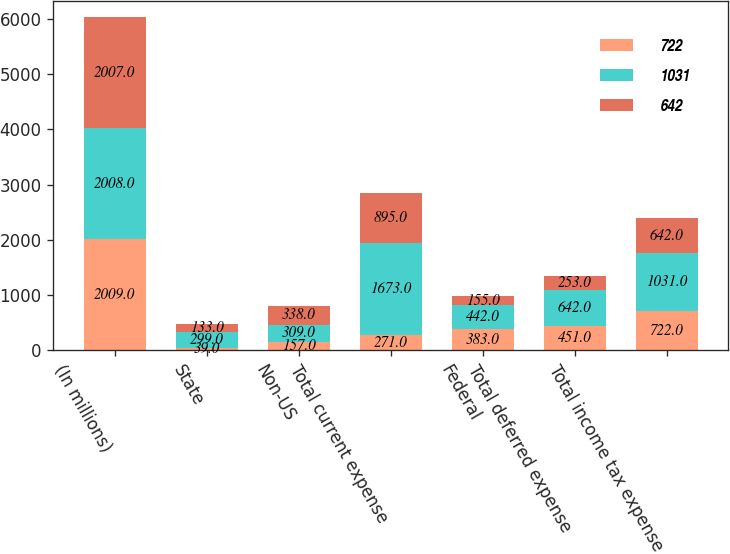<chart> <loc_0><loc_0><loc_500><loc_500><stacked_bar_chart><ecel><fcel>(In millions)<fcel>State<fcel>Non-US<fcel>Total current expense<fcel>Federal<fcel>Total deferred expense<fcel>Total income tax expense<nl><fcel>722<fcel>2009<fcel>39<fcel>157<fcel>271<fcel>383<fcel>451<fcel>722<nl><fcel>1031<fcel>2008<fcel>299<fcel>309<fcel>1673<fcel>442<fcel>642<fcel>1031<nl><fcel>642<fcel>2007<fcel>133<fcel>338<fcel>895<fcel>155<fcel>253<fcel>642<nl></chart> 